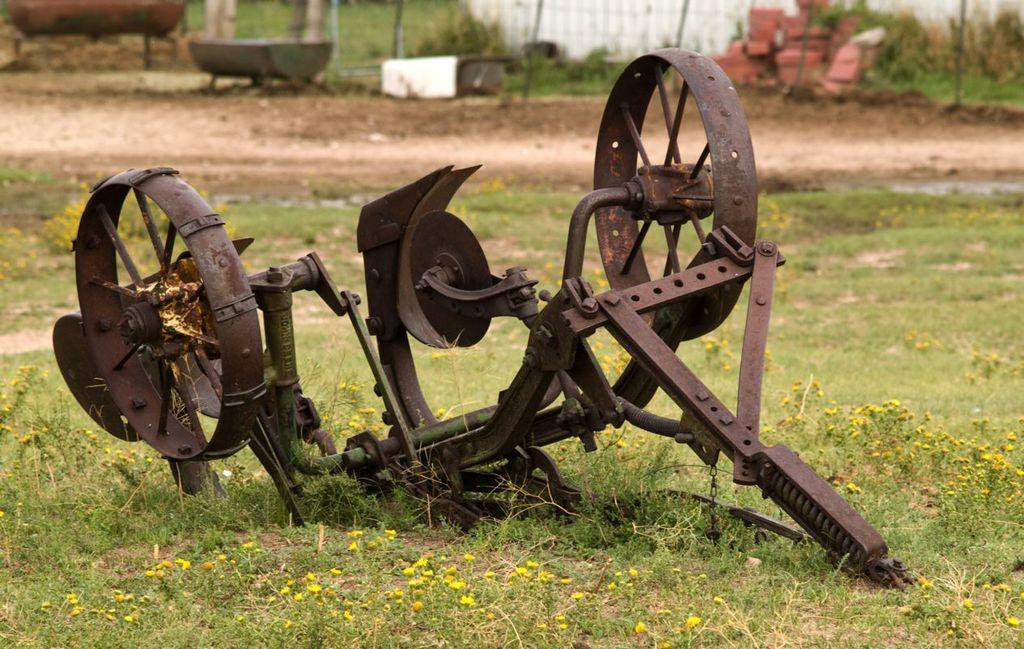What type of iron object can be seen in the image? There is an iron object in the image, but the specific type cannot be determined from the facts provided. What type of vegetation is present in the image? There is grass in the image. What type of barrier can be seen in the image? There is a fence in the image. What type of building material is present in the image? There are bricks in the image. What type of ground is present in the image? Soil is present in the image. What type of appliance is used to make cream in the image? There is no appliance or cream present in the image. What type of development is taking place in the image? There is no development or construction activity present in the image. 